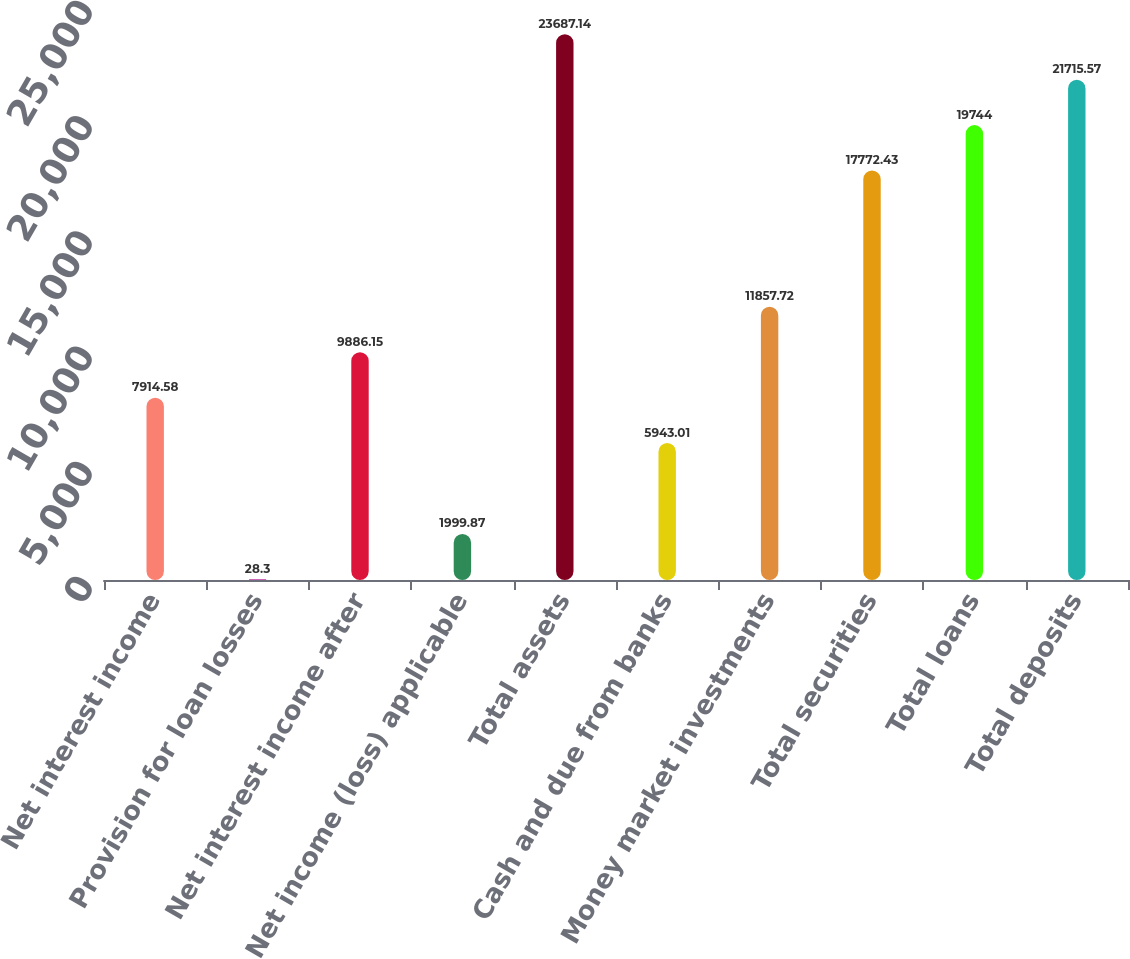Convert chart. <chart><loc_0><loc_0><loc_500><loc_500><bar_chart><fcel>Net interest income<fcel>Provision for loan losses<fcel>Net interest income after<fcel>Net income (loss) applicable<fcel>Total assets<fcel>Cash and due from banks<fcel>Money market investments<fcel>Total securities<fcel>Total loans<fcel>Total deposits<nl><fcel>7914.58<fcel>28.3<fcel>9886.15<fcel>1999.87<fcel>23687.1<fcel>5943.01<fcel>11857.7<fcel>17772.4<fcel>19744<fcel>21715.6<nl></chart> 